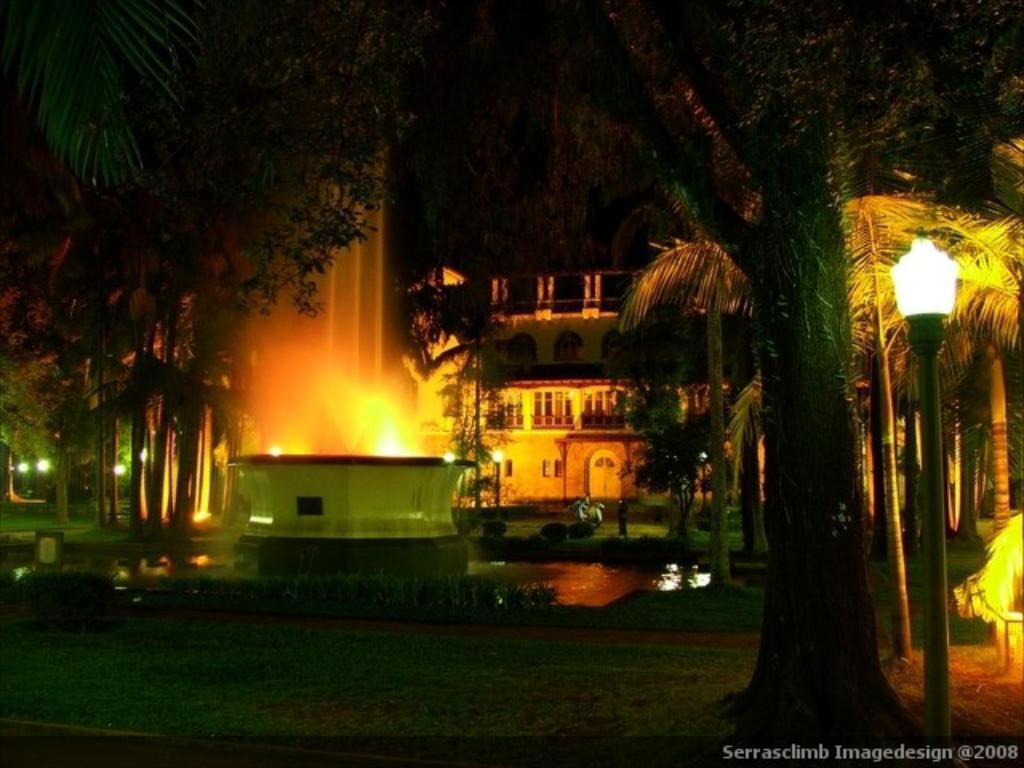In one or two sentences, can you explain what this image depicts? In this image there is a building, in front of the building there is a fountain, trees, a few street lights, plants and the background is dark. 